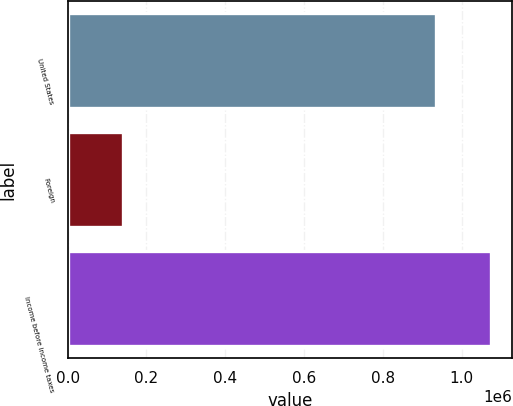Convert chart to OTSL. <chart><loc_0><loc_0><loc_500><loc_500><bar_chart><fcel>United States<fcel>Foreign<fcel>Income before income taxes<nl><fcel>934476<fcel>139864<fcel>1.07434e+06<nl></chart> 